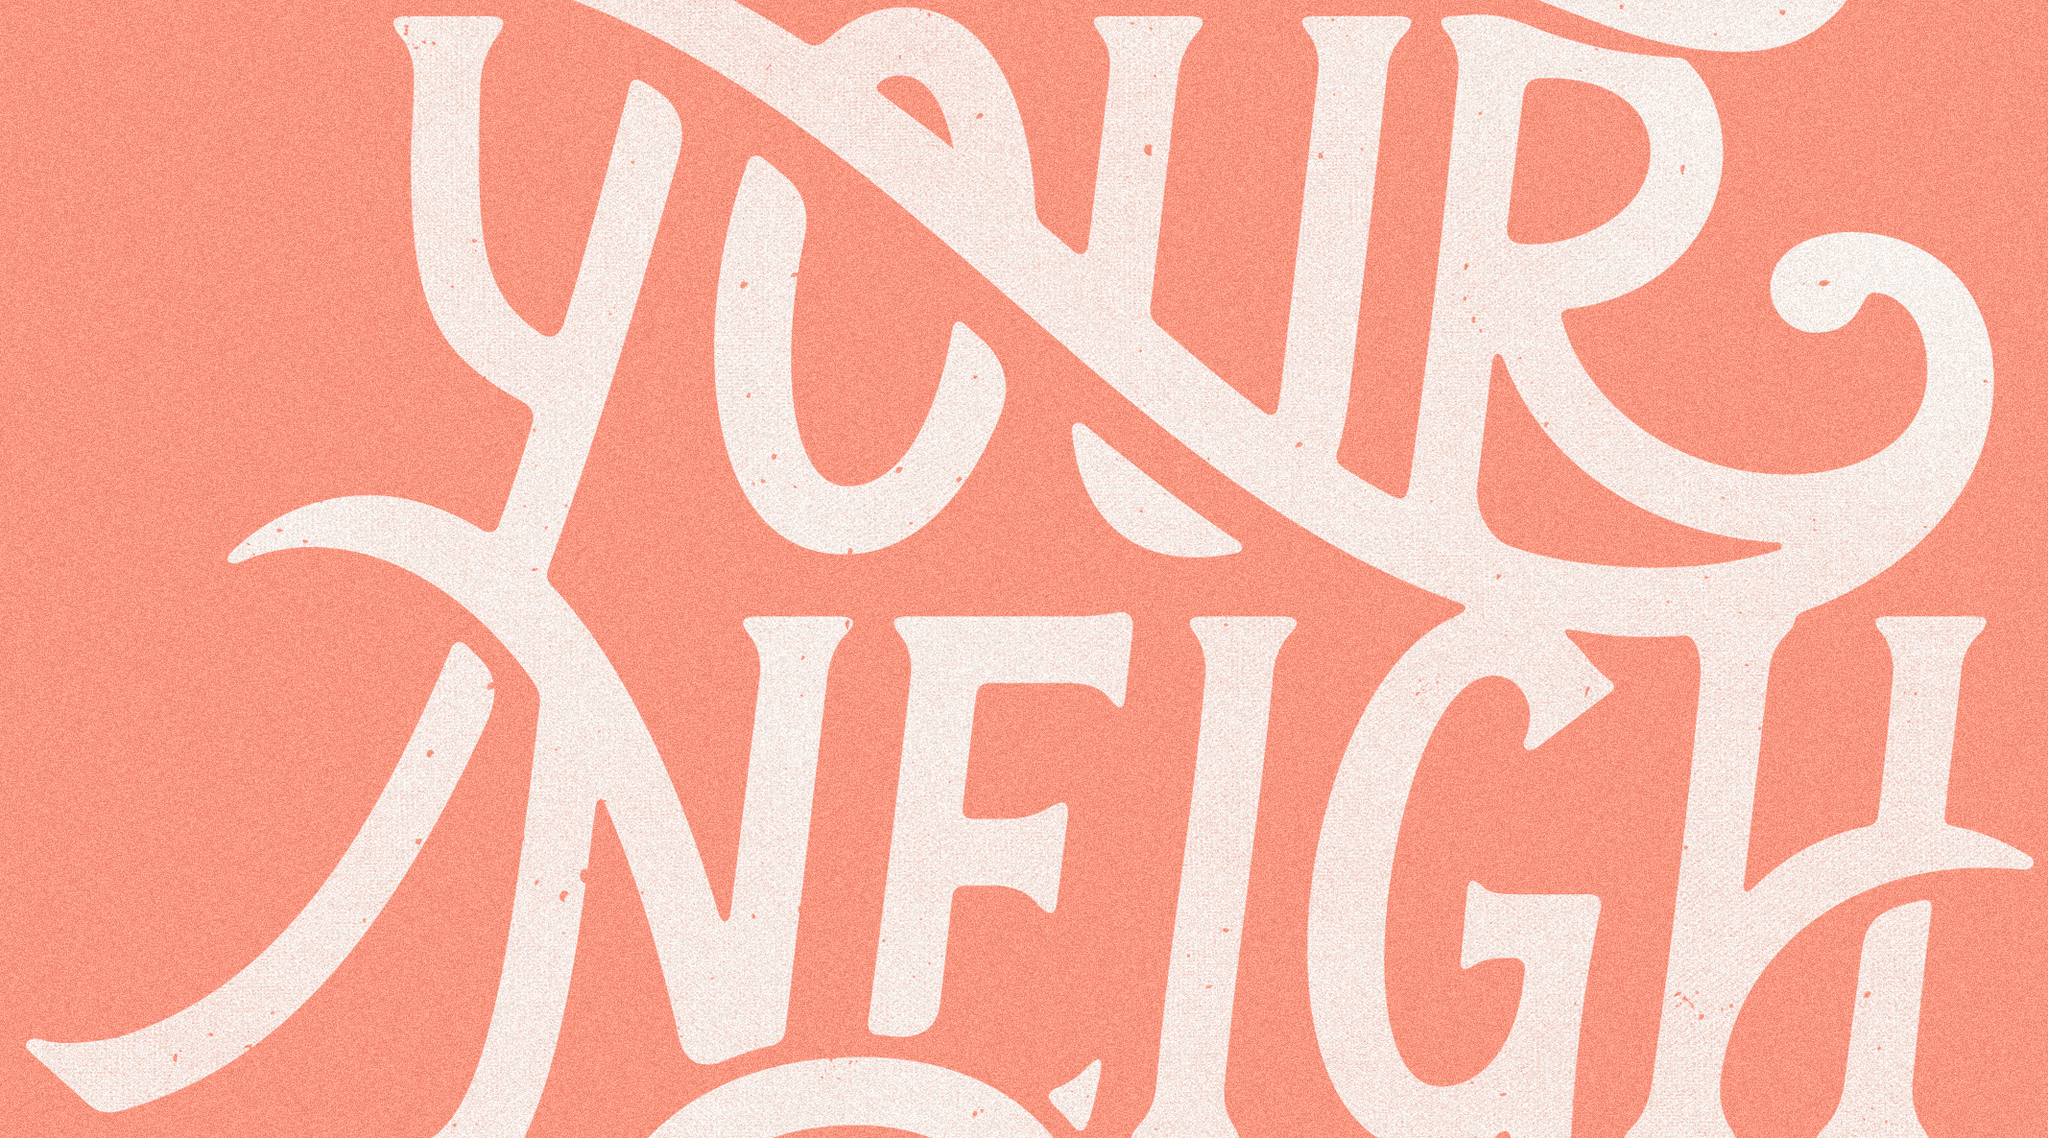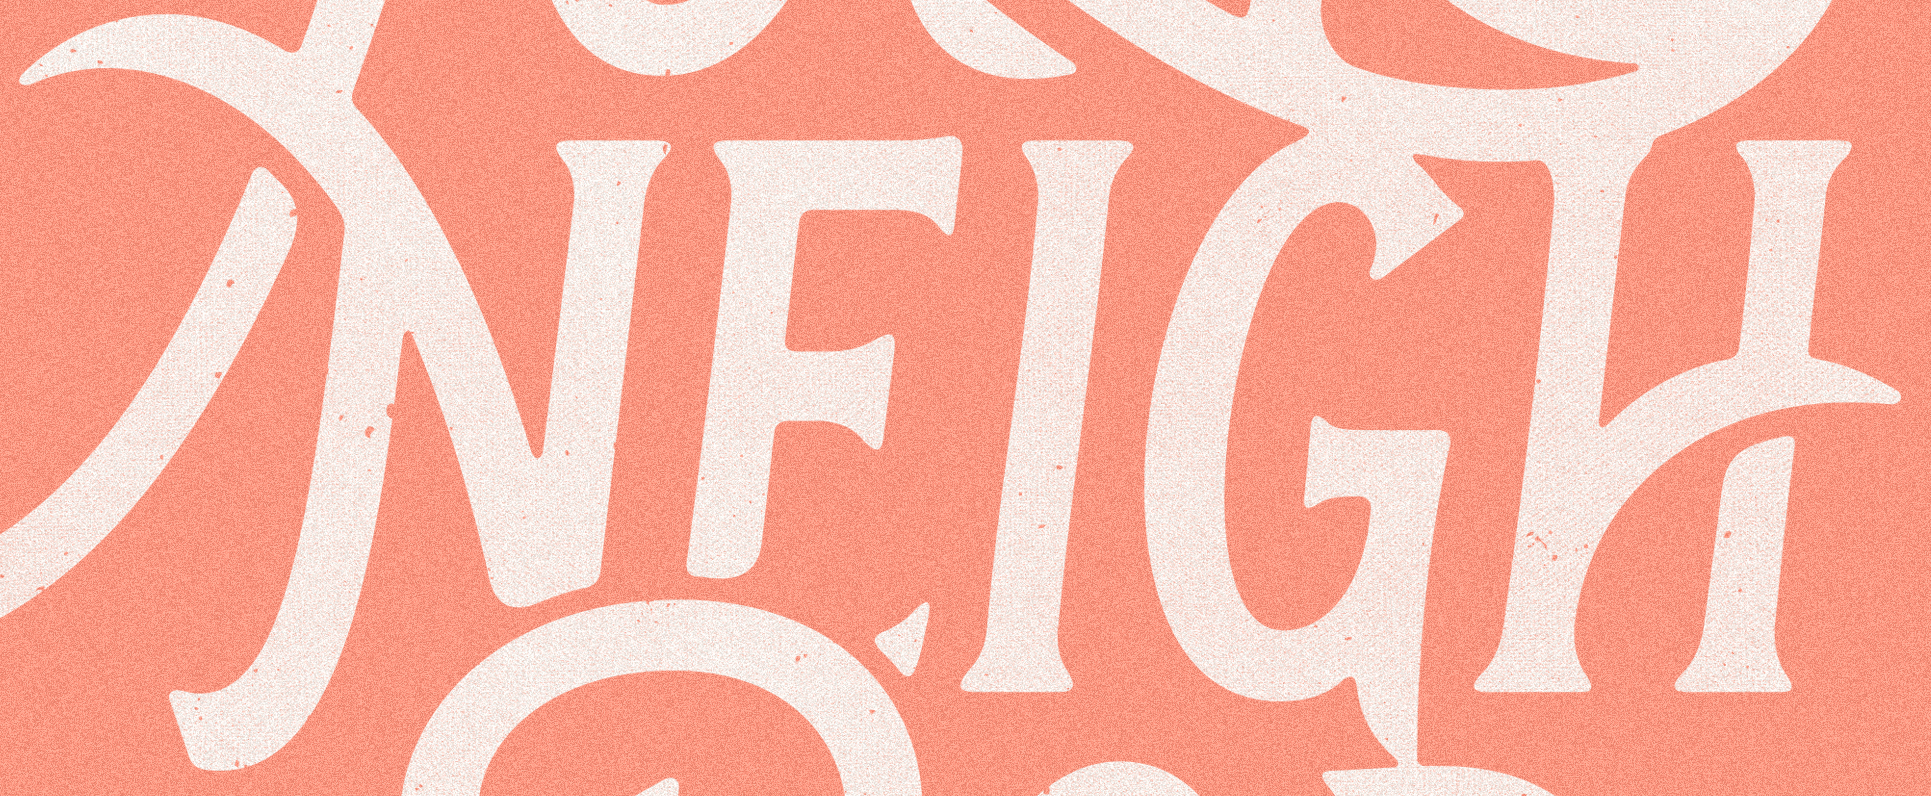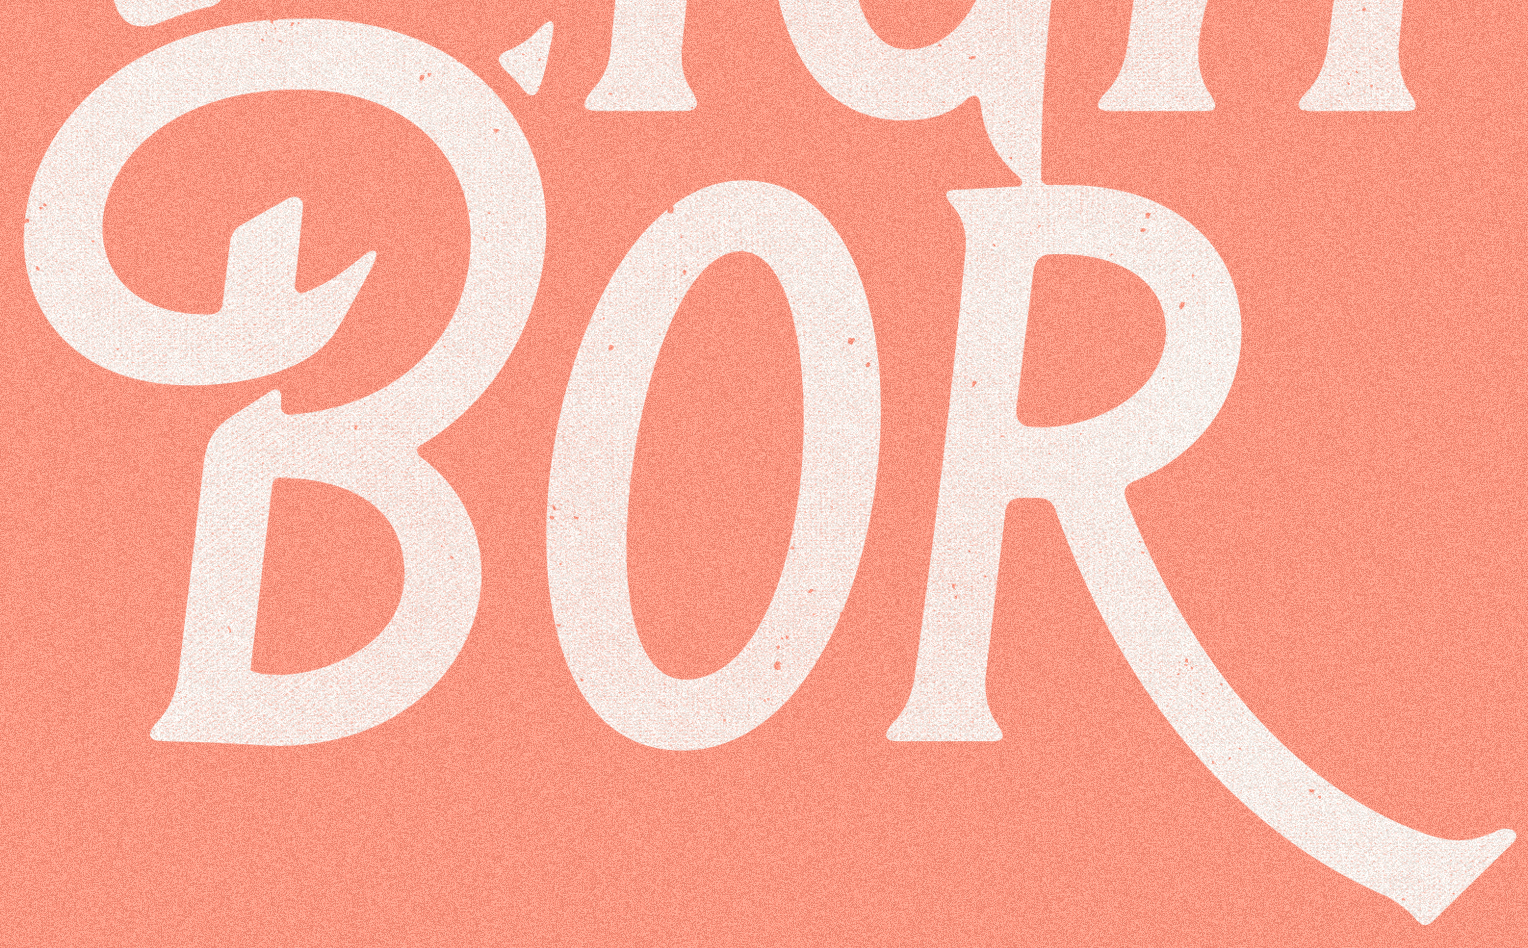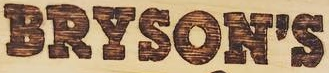Read the text content from these images in order, separated by a semicolon. YOUR; NEIGH; BOR; BRYSON'S 